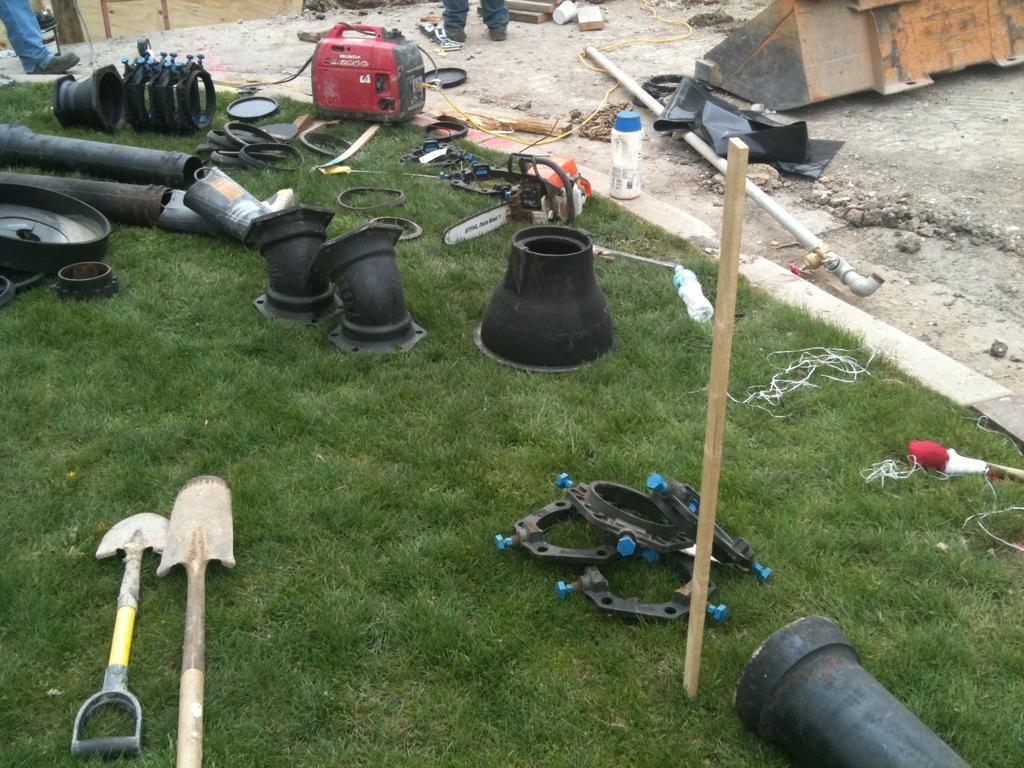Describe this image in one or two sentences. In this image I see the green grass, a wooden stick and I see number of black color things and I see the tools over here and I see an electronic equipment over here and I see 2 persons legs and I see few stones and I see a pipe over here. 